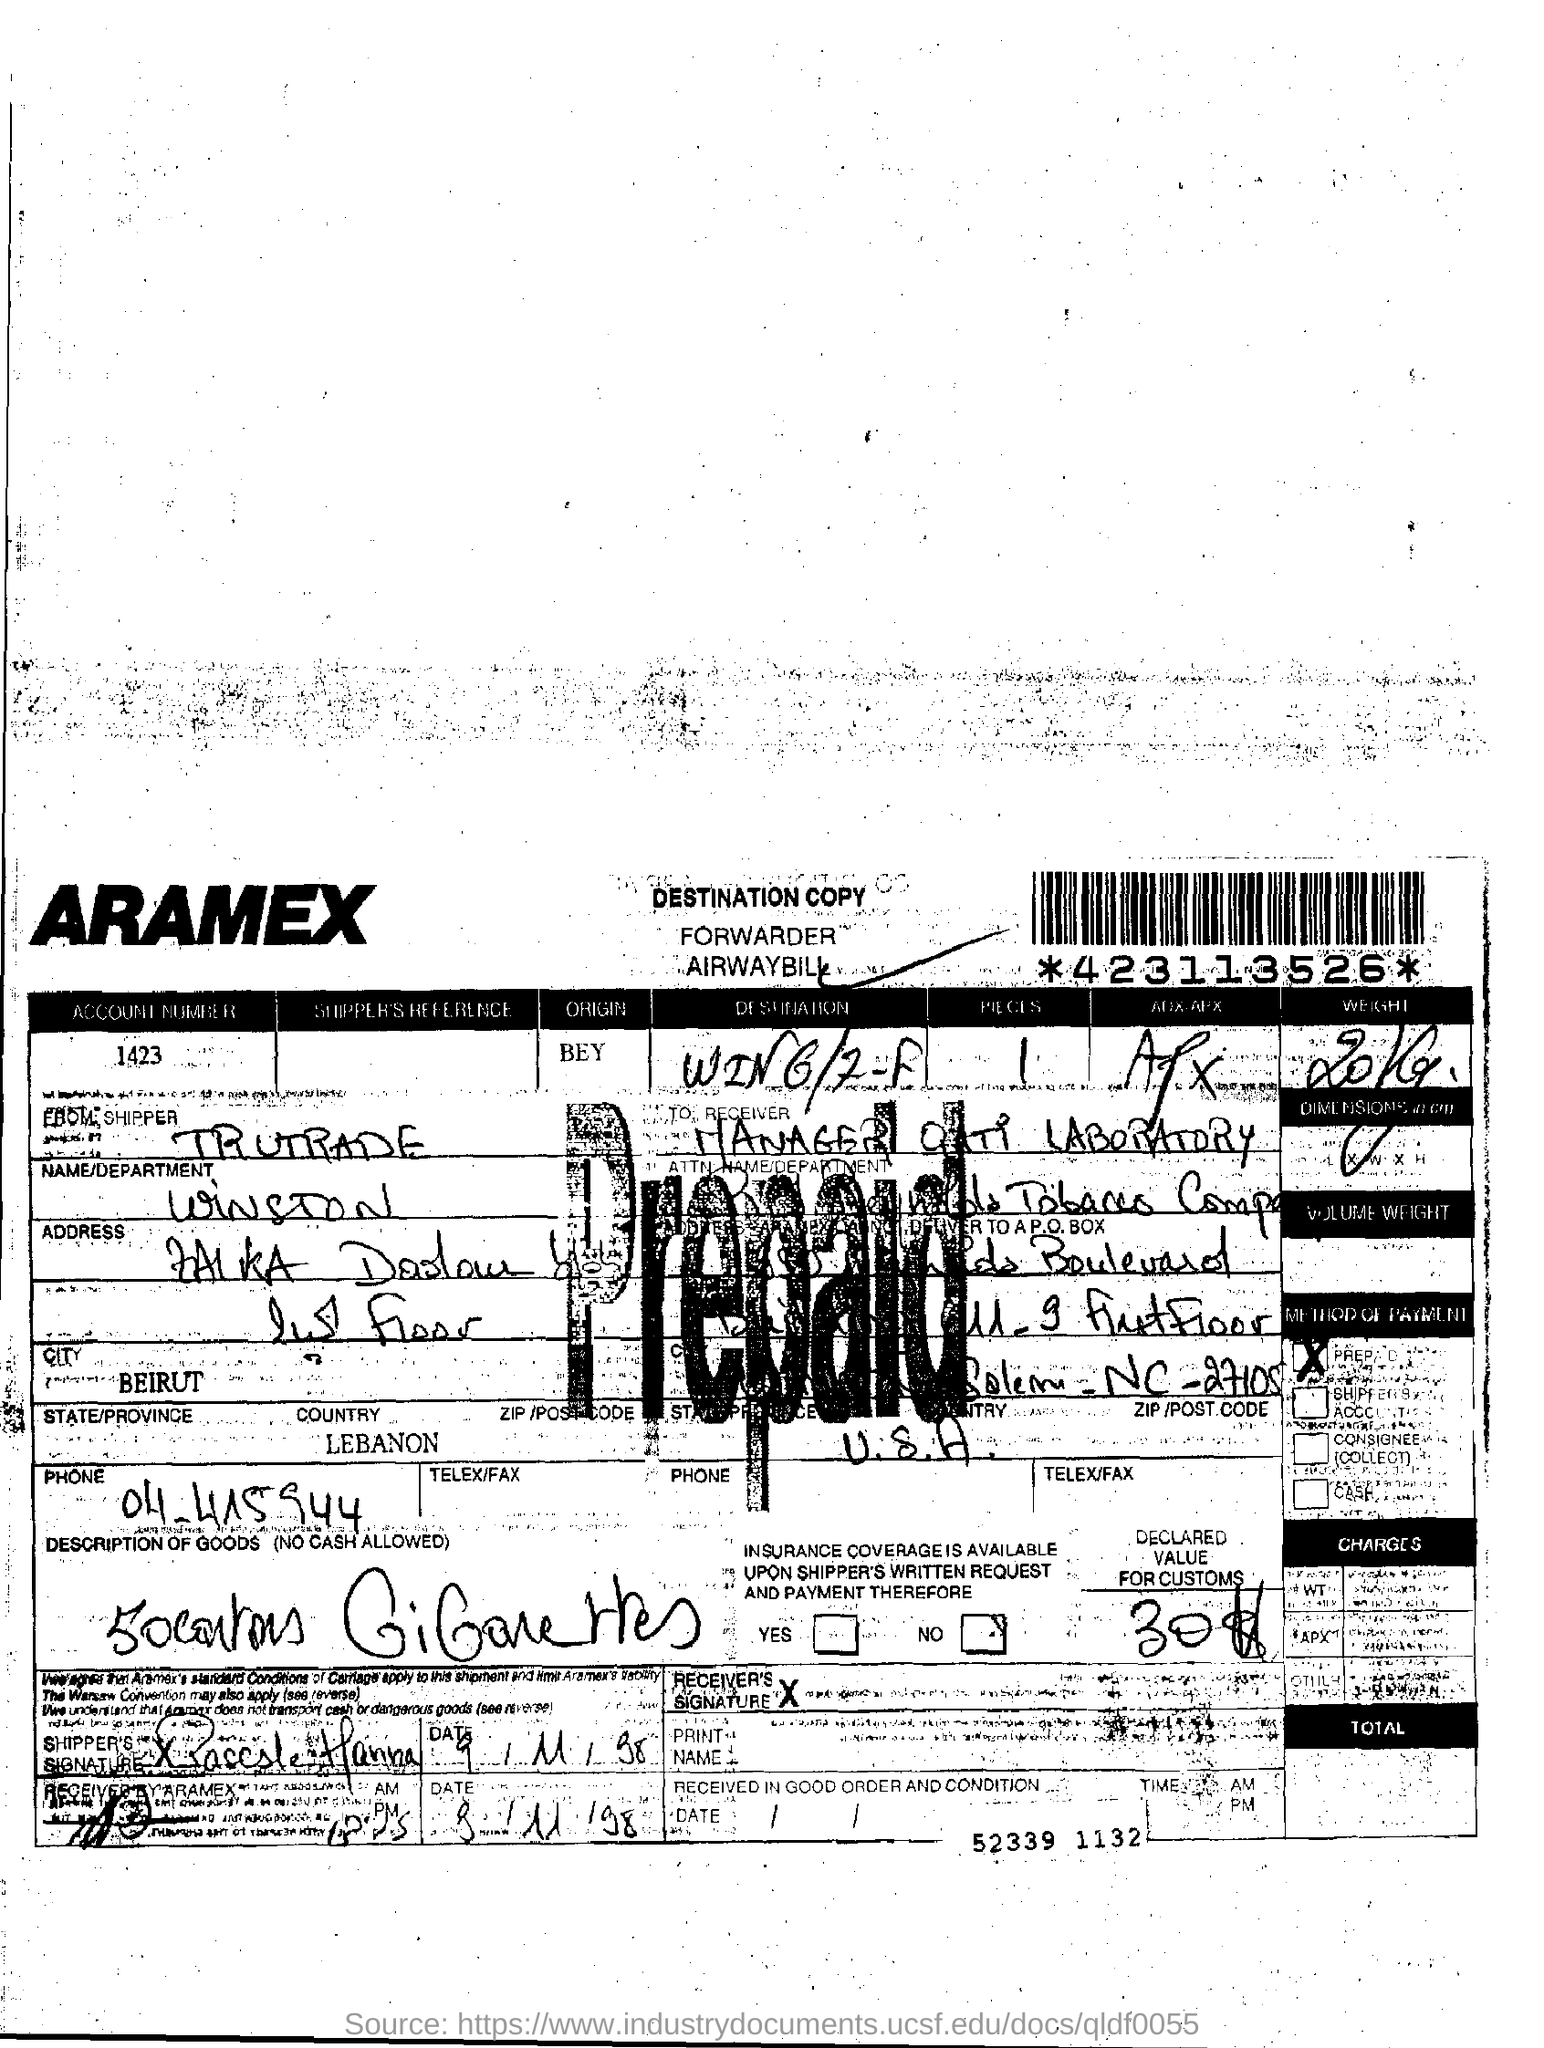List a handful of essential elements in this visual. LEBANON is the name of the country. The origin of BEYONCE is not known. My name is Winston and I belong to the Department. Beirut is the name of the city. 